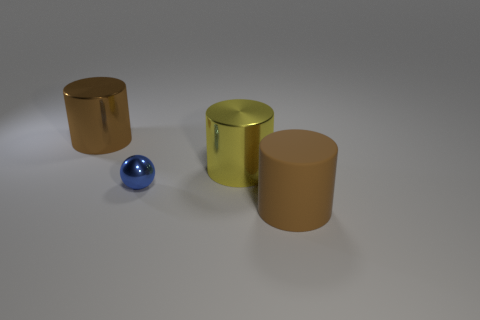Subtract all purple cylinders. Subtract all green blocks. How many cylinders are left? 3 Subtract all brown cylinders. How many yellow spheres are left? 0 Add 4 big browns. How many tiny things exist? 0 Subtract all large yellow things. Subtract all big cylinders. How many objects are left? 0 Add 4 yellow cylinders. How many yellow cylinders are left? 5 Add 4 big cyan rubber balls. How many big cyan rubber balls exist? 4 Add 3 brown metallic cylinders. How many objects exist? 7 Subtract all yellow cylinders. How many cylinders are left? 2 Subtract all large yellow cylinders. How many cylinders are left? 2 Subtract 1 brown cylinders. How many objects are left? 3 